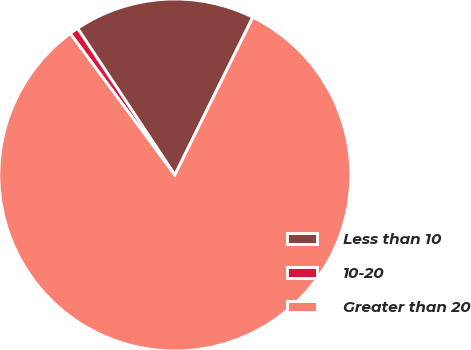<chart> <loc_0><loc_0><loc_500><loc_500><pie_chart><fcel>Less than 10<fcel>10-20<fcel>Greater than 20<nl><fcel>16.63%<fcel>0.81%<fcel>82.55%<nl></chart> 